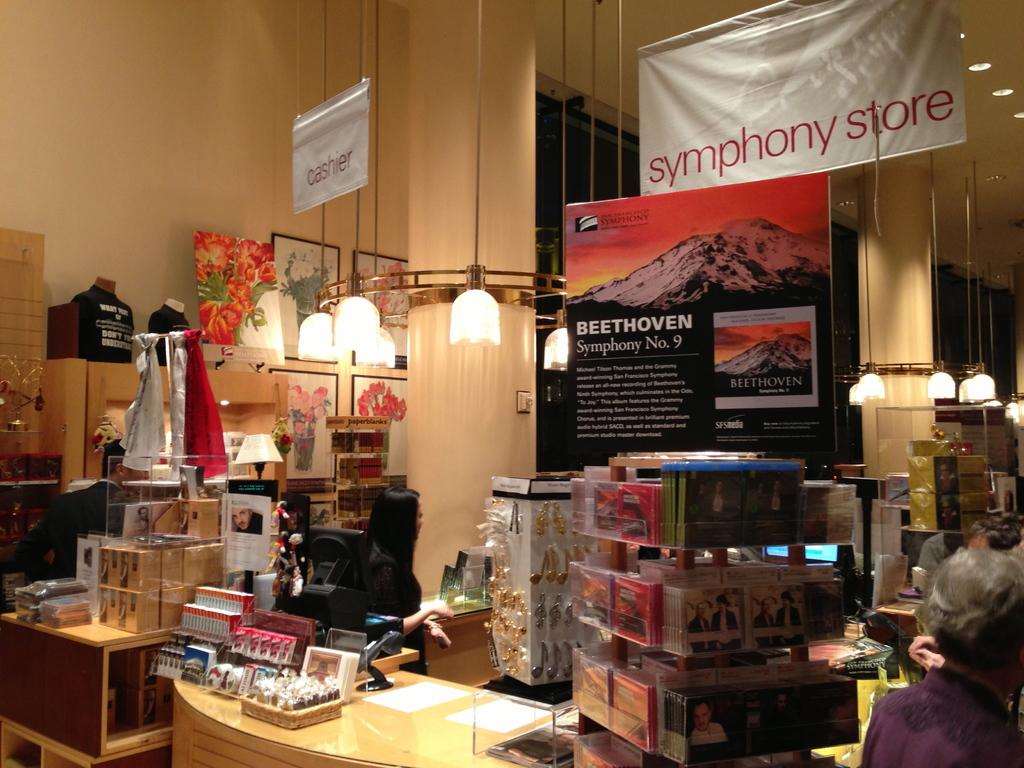<image>
Give a short and clear explanation of the subsequent image. Music store containing Beethoven Symphony #9 collections along with a sign that says Symphony Store. 